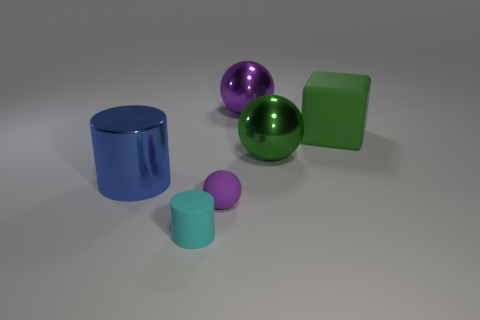What number of other objects are the same size as the cyan object?
Ensure brevity in your answer.  1. There is a purple thing in front of the large green rubber cube; is it the same size as the metallic object that is to the right of the large purple metallic sphere?
Provide a succinct answer. No. Does the cyan object have the same shape as the large purple thing?
Offer a terse response. No. What number of things are purple balls that are in front of the big purple metallic thing or red metal cylinders?
Your response must be concise. 1. Is there a purple matte thing that has the same shape as the green shiny thing?
Offer a very short reply. Yes. Are there an equal number of cyan rubber things in front of the tiny rubber cylinder and small brown blocks?
Your response must be concise. Yes. The shiny object that is the same color as the tiny rubber sphere is what shape?
Give a very brief answer. Sphere. How many matte cylinders have the same size as the green metallic object?
Your answer should be compact. 0. There is a big cylinder; what number of big cylinders are behind it?
Offer a terse response. 0. What is the material of the big sphere that is behind the matte object behind the big metallic cylinder?
Your answer should be compact. Metal. 